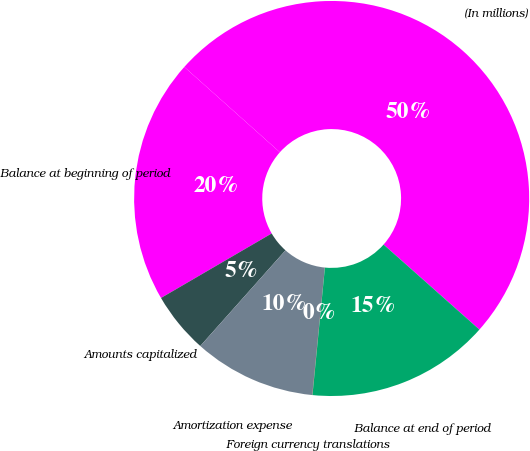<chart> <loc_0><loc_0><loc_500><loc_500><pie_chart><fcel>(In millions)<fcel>Balance at beginning of period<fcel>Amounts capitalized<fcel>Amortization expense<fcel>Foreign currency translations<fcel>Balance at end of period<nl><fcel>49.95%<fcel>20.0%<fcel>5.02%<fcel>10.01%<fcel>0.02%<fcel>15.0%<nl></chart> 